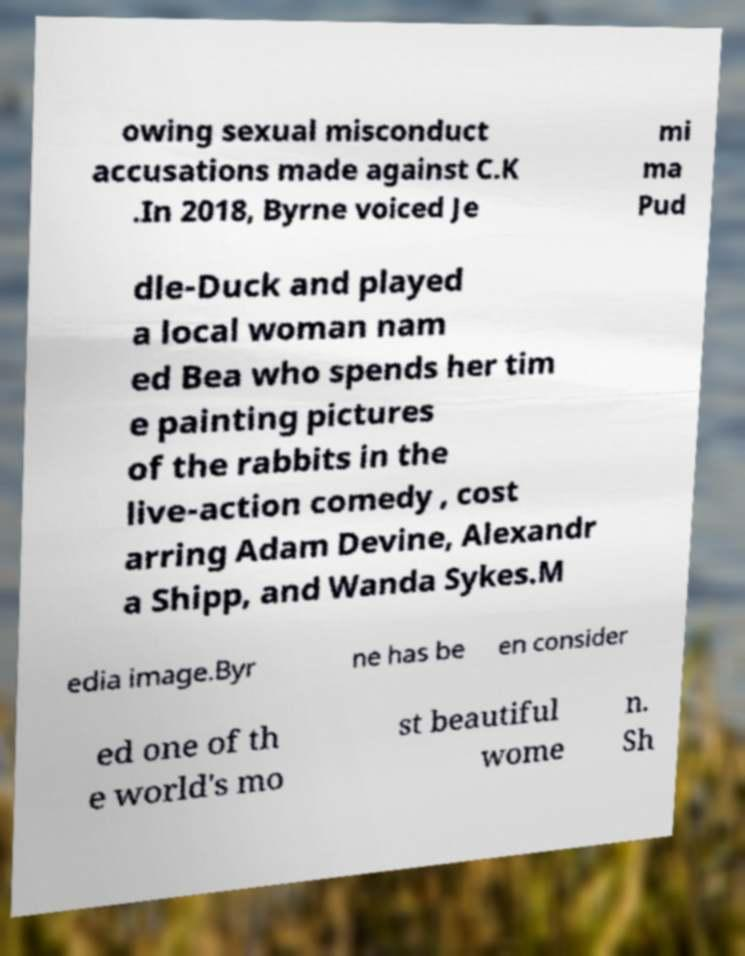Please identify and transcribe the text found in this image. owing sexual misconduct accusations made against C.K .In 2018, Byrne voiced Je mi ma Pud dle-Duck and played a local woman nam ed Bea who spends her tim e painting pictures of the rabbits in the live-action comedy , cost arring Adam Devine, Alexandr a Shipp, and Wanda Sykes.M edia image.Byr ne has be en consider ed one of th e world's mo st beautiful wome n. Sh 